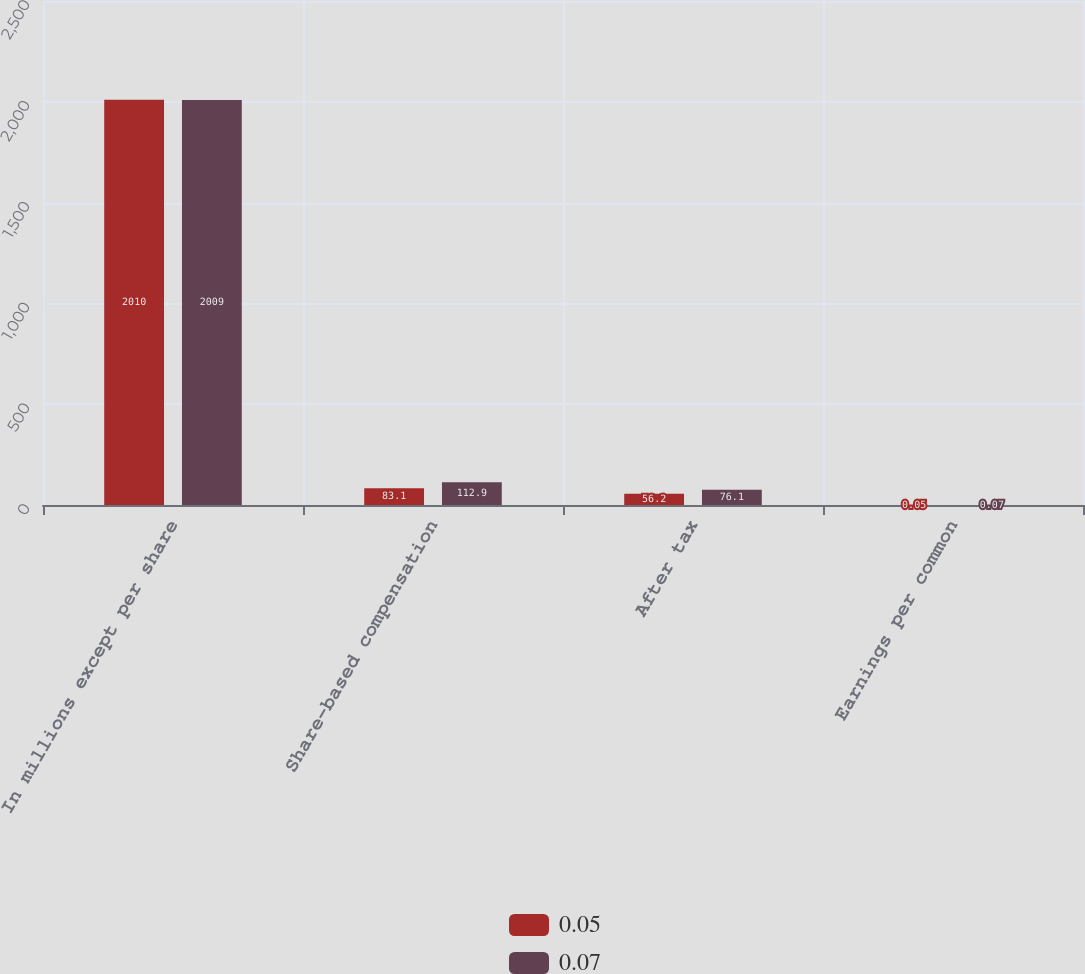<chart> <loc_0><loc_0><loc_500><loc_500><stacked_bar_chart><ecel><fcel>In millions except per share<fcel>Share-based compensation<fcel>After tax<fcel>Earnings per common<nl><fcel>0.05<fcel>2010<fcel>83.1<fcel>56.2<fcel>0.05<nl><fcel>0.07<fcel>2009<fcel>112.9<fcel>76.1<fcel>0.07<nl></chart> 